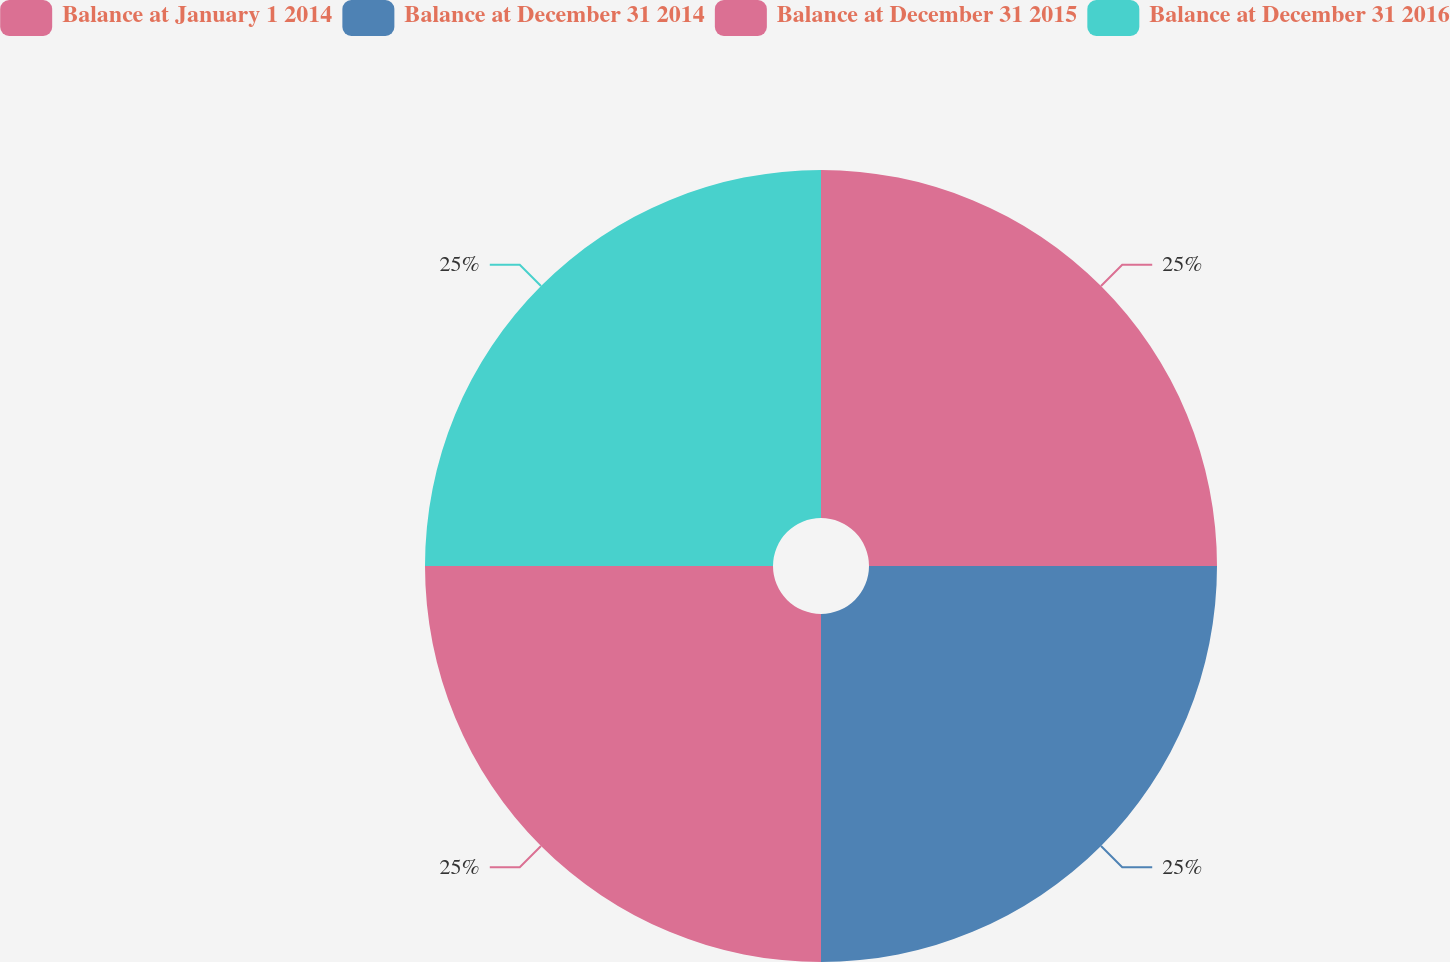<chart> <loc_0><loc_0><loc_500><loc_500><pie_chart><fcel>Balance at January 1 2014<fcel>Balance at December 31 2014<fcel>Balance at December 31 2015<fcel>Balance at December 31 2016<nl><fcel>25.0%<fcel>25.0%<fcel>25.0%<fcel>25.0%<nl></chart> 